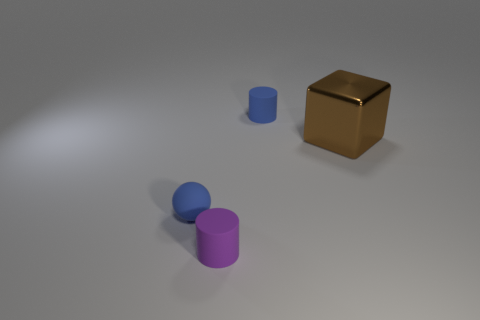Add 3 tiny blue matte balls. How many objects exist? 7 Subtract all blocks. How many objects are left? 3 Add 4 blue rubber cylinders. How many blue rubber cylinders exist? 5 Subtract 1 brown blocks. How many objects are left? 3 Subtract all balls. Subtract all tiny brown metallic cylinders. How many objects are left? 3 Add 1 blocks. How many blocks are left? 2 